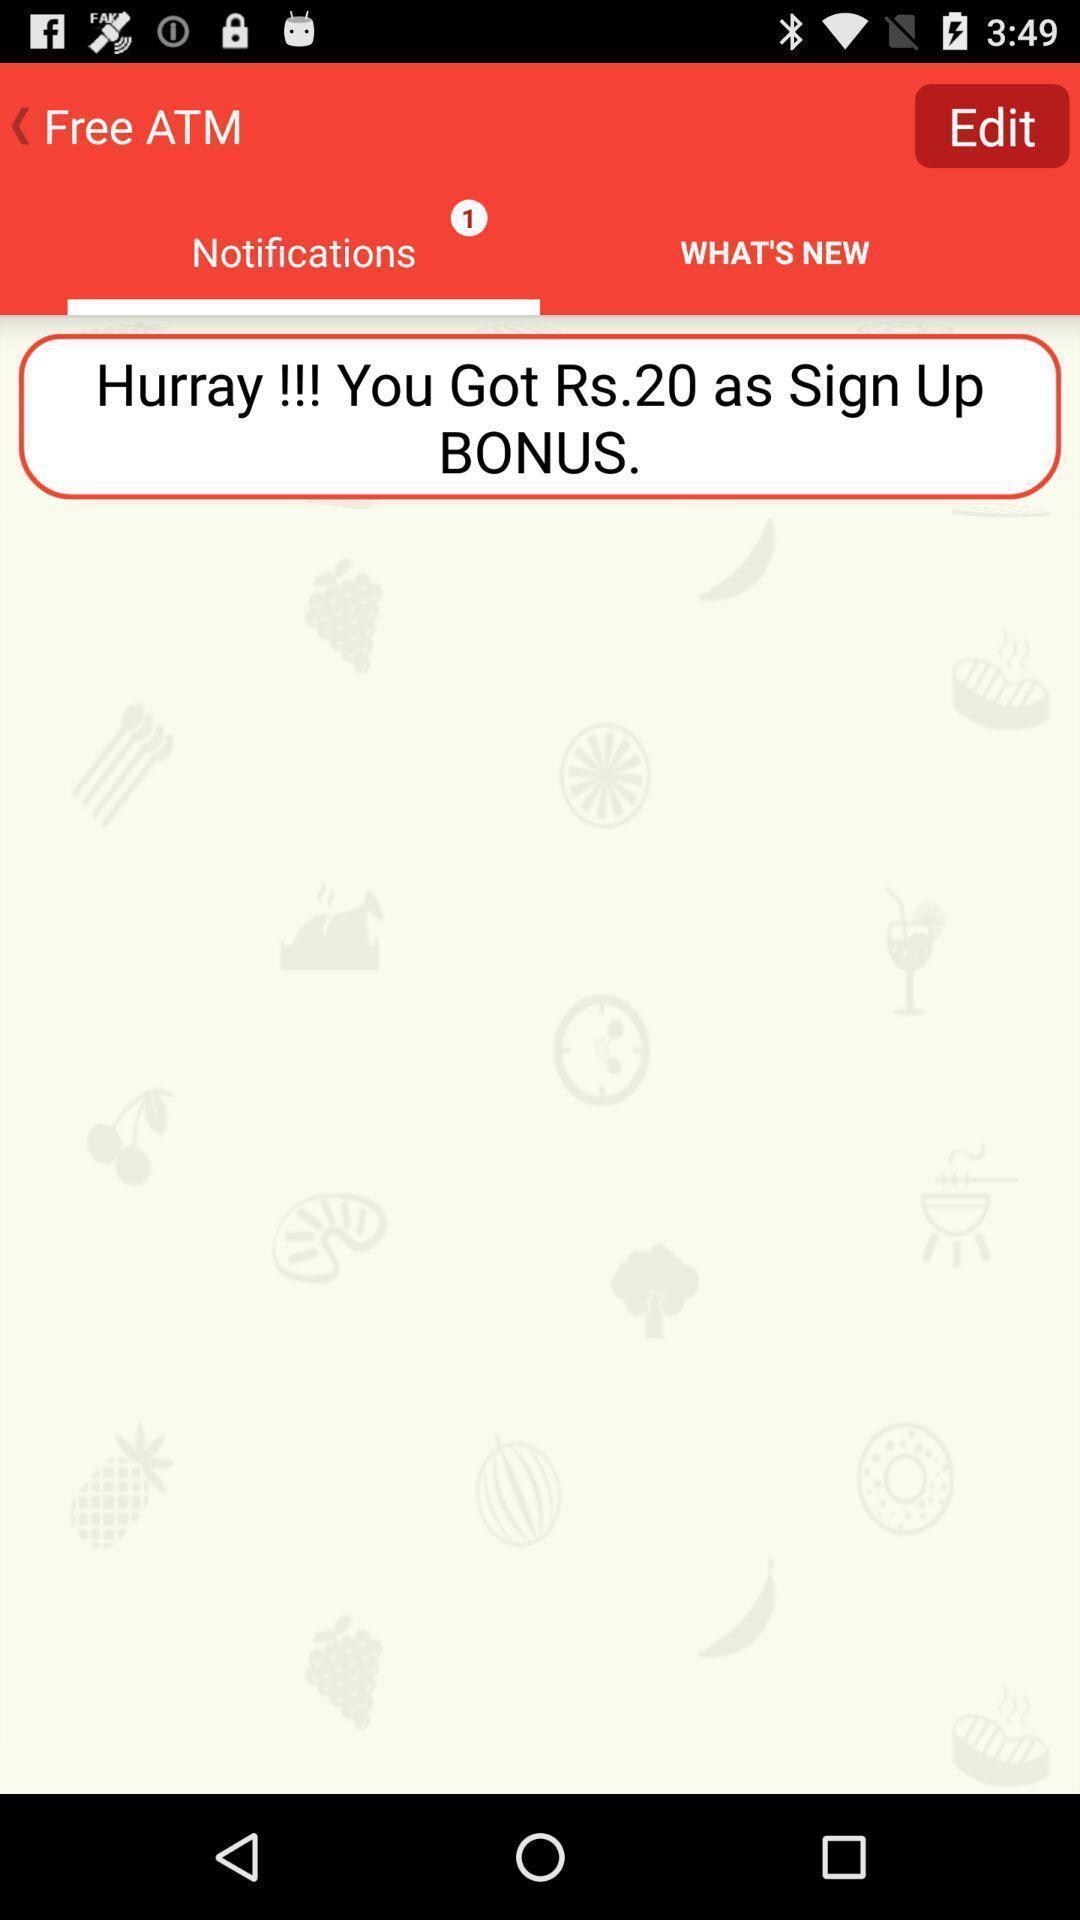Tell me about the visual elements in this screen capture. Page showing information about notifications. 